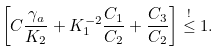<formula> <loc_0><loc_0><loc_500><loc_500>\left [ C \frac { \gamma _ { a } } { K _ { 2 } } + K _ { 1 } ^ { - 2 } \frac { C _ { 1 } } { C _ { 2 } } + \frac { C _ { 3 } } { C _ { 2 } } \right ] \stackrel { ! } { \leq } 1 .</formula> 